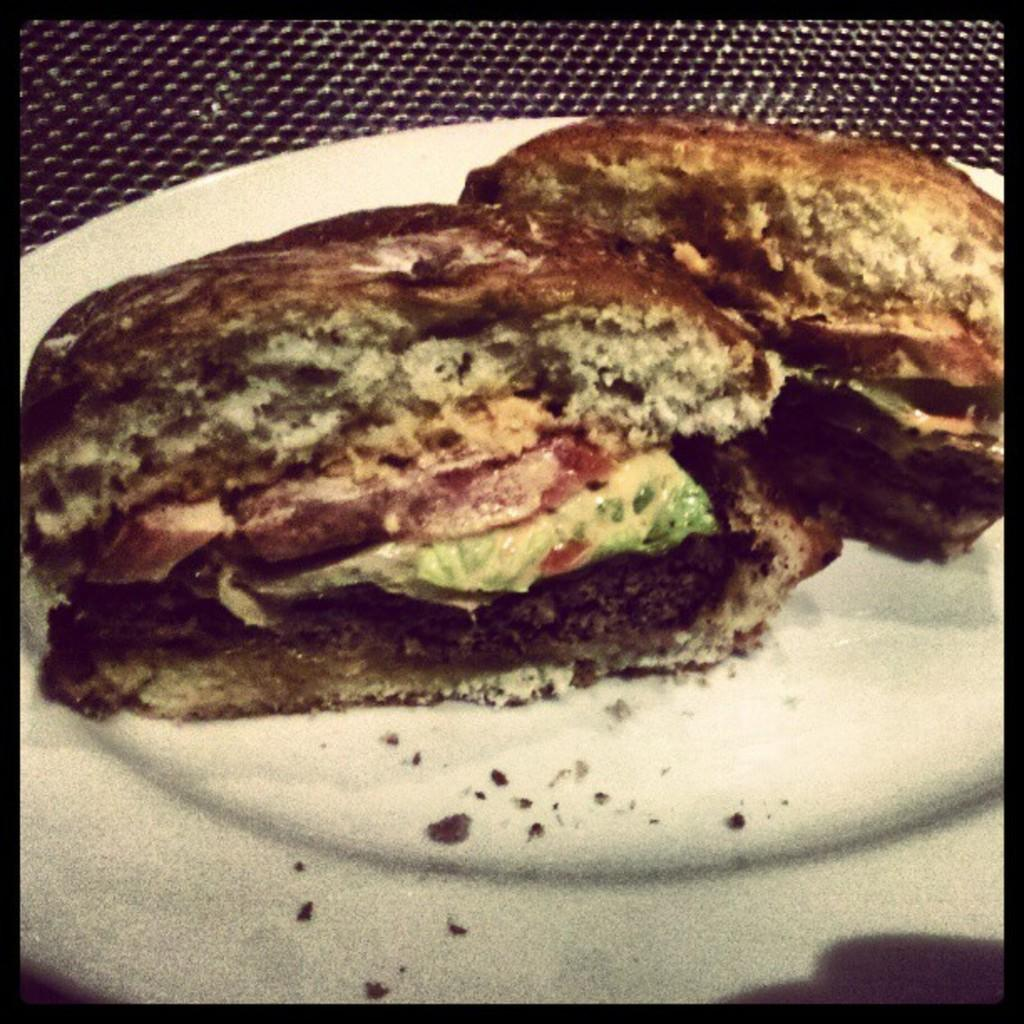What object can be seen in the image that is typically used for serving food? There is a plate in the image that is typically used for serving food. What is on the plate in the image? There is food present on the plate in the image. What type of jelly can be seen on the afterthought in the image? There is no jelly or afterthought present in the image; it only features a plate with food on it. 